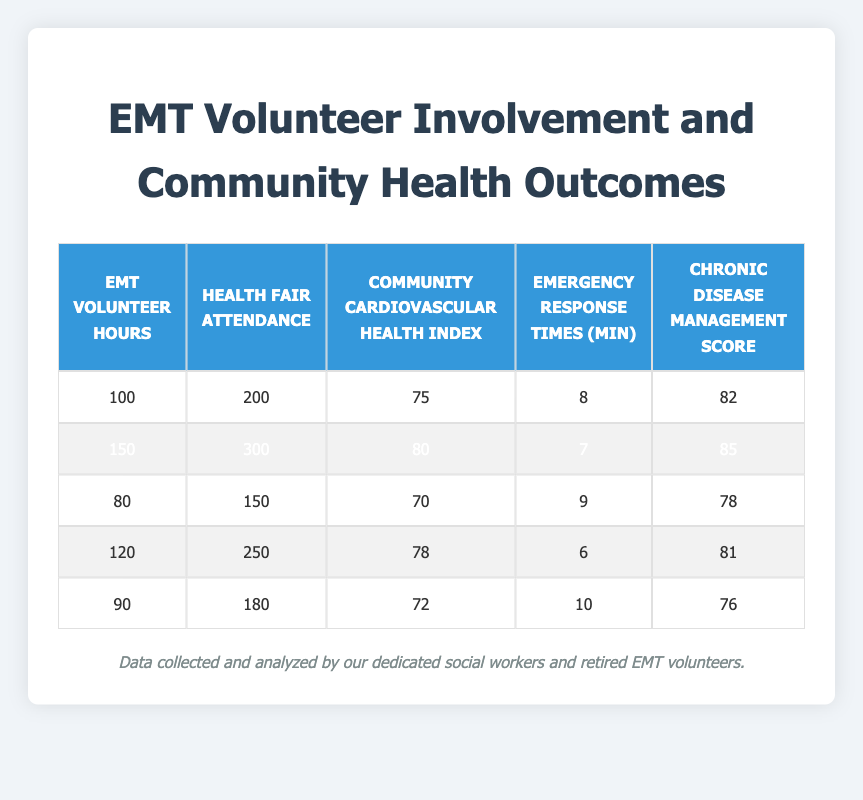What is the value of the Community Cardiovascular Health Index for the EMT volunteer hours of 150? The table shows a row with 150 EMT Volunteer Hours, and the corresponding Community Cardiovascular Health Index in that row is 80.
Answer: 80 How many Health Fair Attendance is associated with the EMT Volunteer Hours of 120? The table indicates that 120 EMT Volunteer Hours correlate with a Health Fair Attendance of 250.
Answer: 250 What is the difference in Chronic Disease Management Scores between the lowest and highest EMT Volunteer Hours? The lowest Chronic Disease Management Score in the table is 76 (for 90 Volunteer Hours) and the highest is 85 (for 150 Volunteer Hours). Thus, the difference is 85 - 76 = 9.
Answer: 9 Is the Community Cardiovascular Health Index higher for the highest Health Fair Attendance compared to the lowest? The highest Health Fair Attendance is 300 (with 150 Volunteer Hours) and has a Cardiovascular Health Index of 80, while the lowest Health Fair Attendance is 150 (with 80 Volunteer Hours) which has an Index of 70. Thus, it is true that the index is higher for the highest attendance.
Answer: Yes What is the average Emergency Response Time across all EMT Volunteer Hours in the table? The Emergency Response Times listed in the table are 8, 7, 9, 6, and 10 minutes. First, we sum these values: 8 + 7 + 9 + 6 + 10 = 40. There are 5 entries, so the average is 40/5 = 8.
Answer: 8 What is the total Health Fair Attendance from volunteers who worked more than 100 hours? Only the EMT Volunteer Hours of 120 and 150 exceed 100, with corresponding Health Fair Attendance of 250 and 300. The total attendance is 250 + 300 = 550.
Answer: 550 Is the Community Cardiovascular Health Index of 90 EMT Volunteer Hours above or below the average Community Cardiovascular Health Index? The Cardiovascular Health Index for 90 Volunteer Hours is 72. The average Index across all data points is calculated as (75 + 80 + 70 + 78 + 72)/5 = 75, making it higher than 72. Therefore, the statement is true.
Answer: Below What is the median number of EMT Volunteer Hours in the dataset? The EMT Volunteer Hours are 100, 150, 80, 120, and 90. Arranging these values in increasing order gives us: 80, 90, 100, 120, 150. The median (the middle value) is 100, as it is the third number in this ordered list.
Answer: 100 